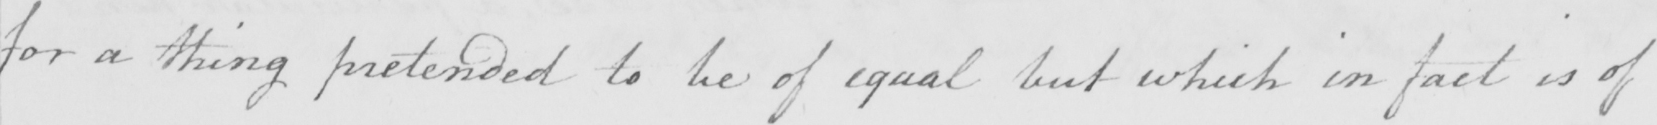Can you tell me what this handwritten text says? for a thing pretended to be of equal but which in fact is of 